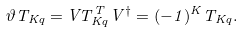Convert formula to latex. <formula><loc_0><loc_0><loc_500><loc_500>\vartheta T _ { K q } = V T ^ { T } _ { K q } V ^ { \dagger } = ( - 1 ) ^ { K } T _ { K q } .</formula> 